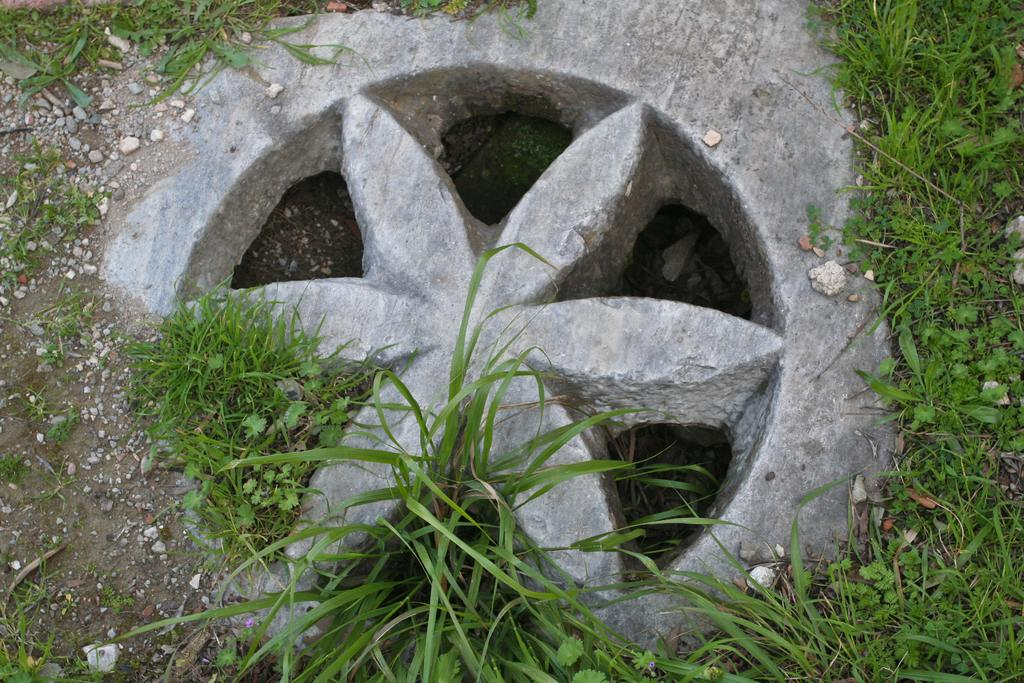What is the shape of the stone in the image? The stone is in the shape of a flower. Where is the stone located in the image? The stone is on the ground. What type of vegetation is present on the ground beside the stone? There is green grass on the ground beside the stone. What is the relation between the stone and the crack in the image? There is no crack mentioned in the image, so it is not possible to determine any relation between the stone and a crack. 